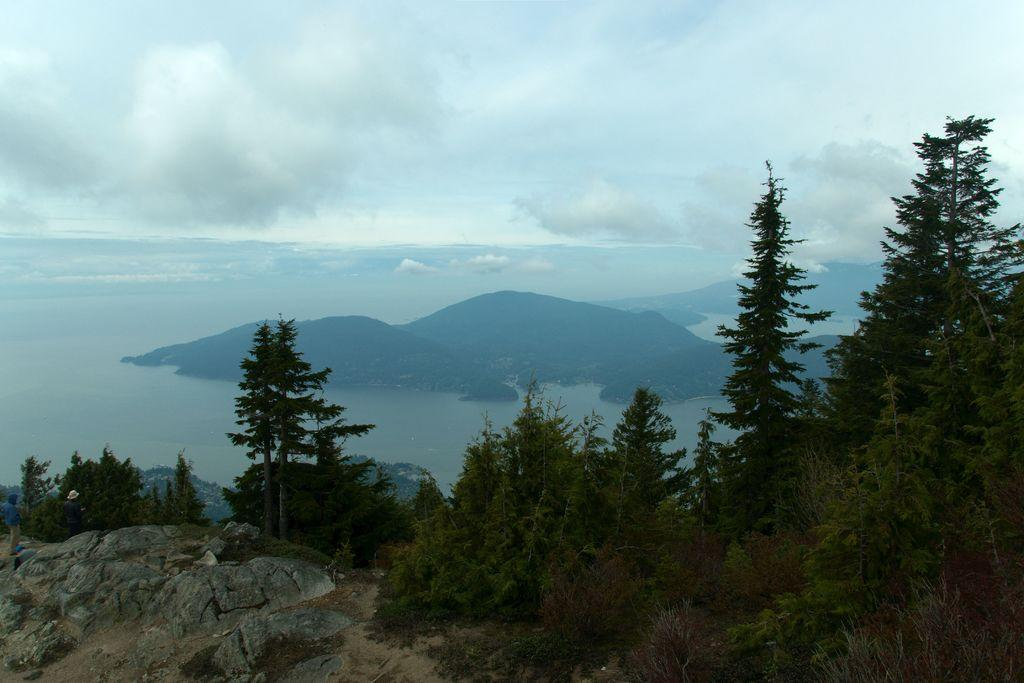What can be seen in the sky in the image? The sky with clouds is visible in the image. What is present in the image besides the sky? There is water, hills, trees, plants, the ground, bushes, rocks, and a person standing on the ground in the image. Can you describe the terrain in the image? The image features hills, trees, plants, bushes, and rocks, indicating a natural landscape. What is the person standing on in the image? The person is standing on the ground in the image. What type of baseball can be seen in the image? There is no baseball present in the image. Can you describe the ladybug's role in the image? There is no ladybug present in the image. 